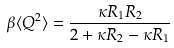Convert formula to latex. <formula><loc_0><loc_0><loc_500><loc_500>\beta \langle Q ^ { 2 } \rangle = \frac { \kappa R _ { 1 } R _ { 2 } } { 2 + \kappa R _ { 2 } - \kappa R _ { 1 } }</formula> 